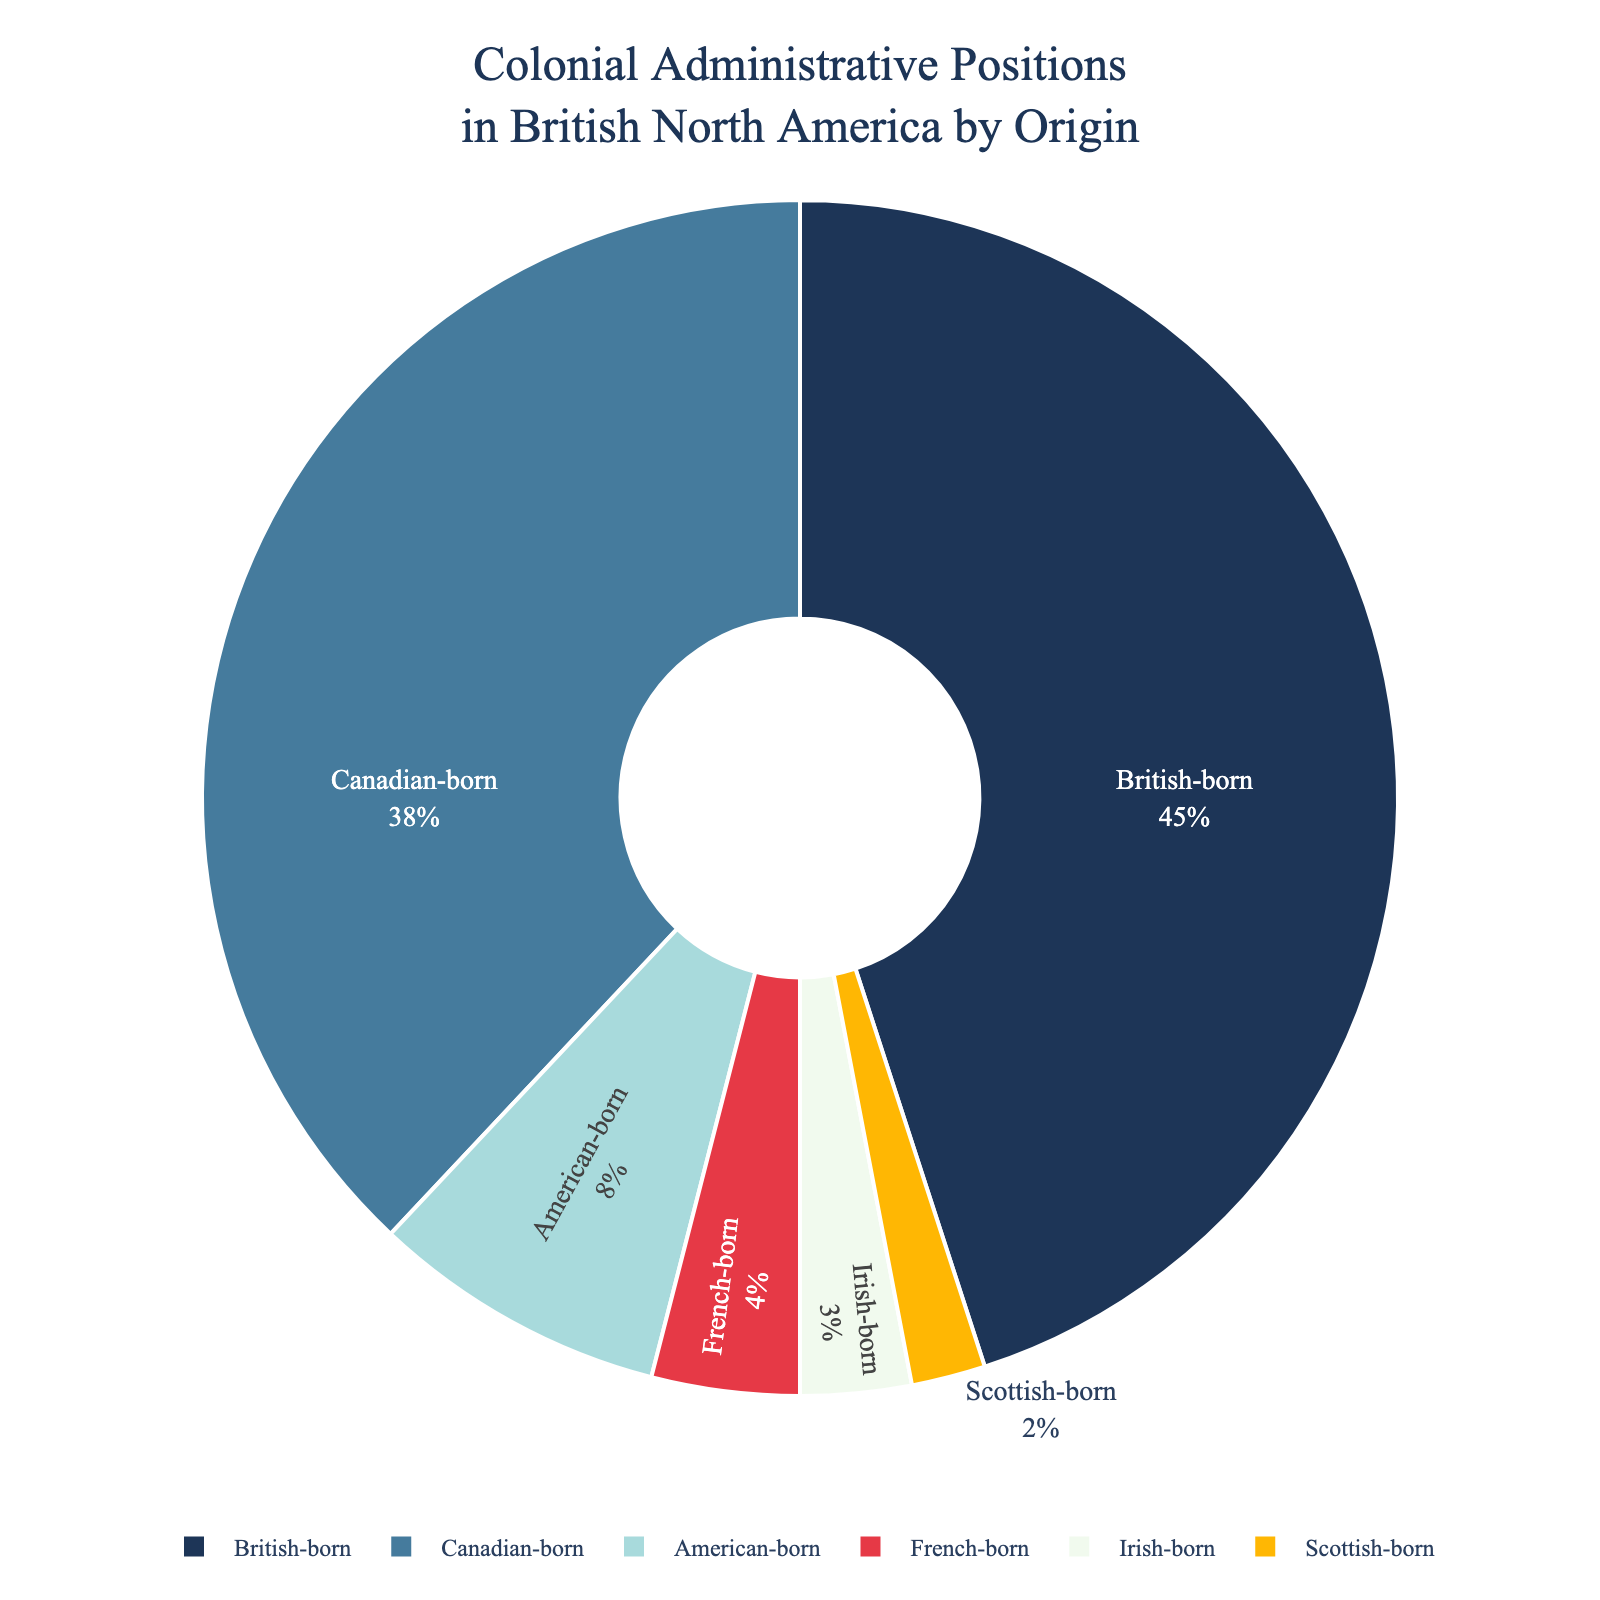What's the largest group in the chart? The largest group can be identified by comparing the percentage values associated with each origin. The British-born group has the highest percentage at 45%.
Answer: British-born What is the sum of the percentages for the Canadian-born and American-born groups? To find the sum, add the percentages of the Canadian-born group (38%) and the American-born group (8%). Thus, 38% + 8% = 46%.
Answer: 46% Which group is just under 5%? The group with a percentage just under 5% can be determined by inspecting the percentage labels. The French-born group has a percentage of 4%.
Answer: French-born Are the Irish-born and Scottish-born groups equal in terms of percentage? By comparing the percentage values for Irish-born (3%) and Scottish-born (2%) groups, it is clear that they are not equal.
Answer: No What percentage of the colonial administrative positions is taken by individuals from European origins other than British-born? Sum the percentages for American-born (8%), French-born (4%), Irish-born (3%), and Scottish-born (2%) groups. So, 8% + 4% + 3% + 2% = 17%.
Answer: 17% Which group has the smallest representation, and what is its percentage? By comparing all group percentages, the Scottish-born group has the smallest representation with 2%.
Answer: Scottish-born, 2% How much larger is the British-born group compared to the Canadian-born group? Subtract the percentage of the Canadian-born group from the British-born group: 45% - 38% = 7%.
Answer: 7% Is the percentage of British-born individuals greater than the combined percentage of French-born and Irish-born individuals? First, calculate the combined percentage of French-born and Irish-born groups: 4% + 3% = 7%. Then, compare 45% (British-born) with 7%, so 45% is greater.
Answer: Yes What is the total percentage represented by the three largest groups? Identify the three largest groups: British-born (45%), Canadian-born (38%), and American-born (8%). Sum their percentages: 45% + 38% + 8% = 91%.
Answer: 91% What is the difference between the percentages of the Canadian-born and the American-born groups? Subtract the percentage of the American-born group from the Canadian-born group: 38% - 8% = 30%.
Answer: 30% 